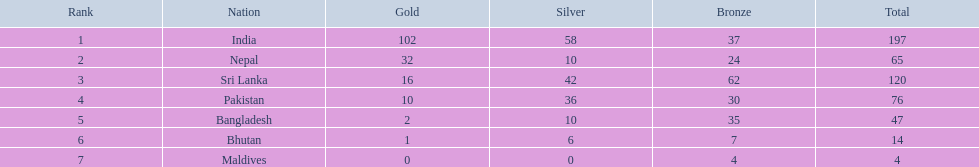Which countries can be found in the table? India, Nepal, Sri Lanka, Pakistan, Bangladesh, Bhutan, Maldives. Which one isn't india? Nepal, Sri Lanka, Pakistan, Bangladesh, Bhutan, Maldives. Out of these, which one comes first? Nepal. 